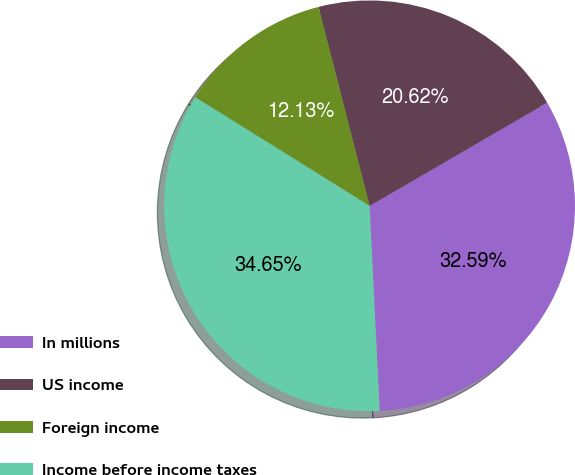Convert chart. <chart><loc_0><loc_0><loc_500><loc_500><pie_chart><fcel>In millions<fcel>US income<fcel>Foreign income<fcel>Income before income taxes<nl><fcel>32.59%<fcel>20.62%<fcel>12.13%<fcel>34.65%<nl></chart> 